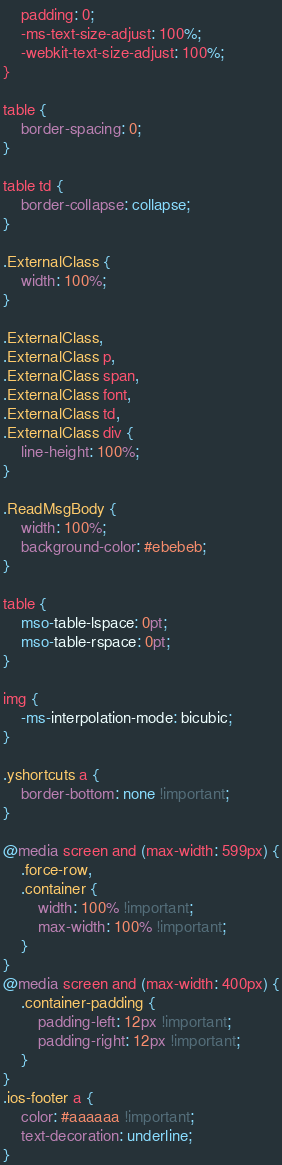Convert code to text. <code><loc_0><loc_0><loc_500><loc_500><_CSS_>    padding: 0;
    -ms-text-size-adjust: 100%;
    -webkit-text-size-adjust: 100%;
}

table {
    border-spacing: 0;
}

table td {
    border-collapse: collapse;
}

.ExternalClass {
    width: 100%;
}

.ExternalClass,
.ExternalClass p,
.ExternalClass span,
.ExternalClass font,
.ExternalClass td,
.ExternalClass div {
    line-height: 100%;
}

.ReadMsgBody {
    width: 100%;
    background-color: #ebebeb;
}

table {
    mso-table-lspace: 0pt;
    mso-table-rspace: 0pt;
}

img {
    -ms-interpolation-mode: bicubic;
}

.yshortcuts a {
    border-bottom: none !important;
}

@media screen and (max-width: 599px) {
    .force-row,
    .container {
        width: 100% !important;
        max-width: 100% !important;
    }
}
@media screen and (max-width: 400px) {
    .container-padding {
        padding-left: 12px !important;
        padding-right: 12px !important;
    }
}
.ios-footer a {
    color: #aaaaaa !important;
    text-decoration: underline;
}</code> 